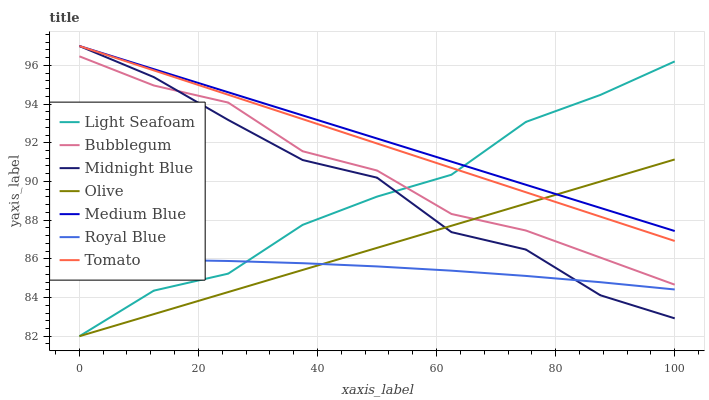Does Royal Blue have the minimum area under the curve?
Answer yes or no. Yes. Does Medium Blue have the maximum area under the curve?
Answer yes or no. Yes. Does Midnight Blue have the minimum area under the curve?
Answer yes or no. No. Does Midnight Blue have the maximum area under the curve?
Answer yes or no. No. Is Tomato the smoothest?
Answer yes or no. Yes. Is Midnight Blue the roughest?
Answer yes or no. Yes. Is Medium Blue the smoothest?
Answer yes or no. No. Is Medium Blue the roughest?
Answer yes or no. No. Does Olive have the lowest value?
Answer yes or no. Yes. Does Midnight Blue have the lowest value?
Answer yes or no. No. Does Medium Blue have the highest value?
Answer yes or no. Yes. Does Bubblegum have the highest value?
Answer yes or no. No. Is Royal Blue less than Tomato?
Answer yes or no. Yes. Is Tomato greater than Royal Blue?
Answer yes or no. Yes. Does Tomato intersect Midnight Blue?
Answer yes or no. Yes. Is Tomato less than Midnight Blue?
Answer yes or no. No. Is Tomato greater than Midnight Blue?
Answer yes or no. No. Does Royal Blue intersect Tomato?
Answer yes or no. No. 